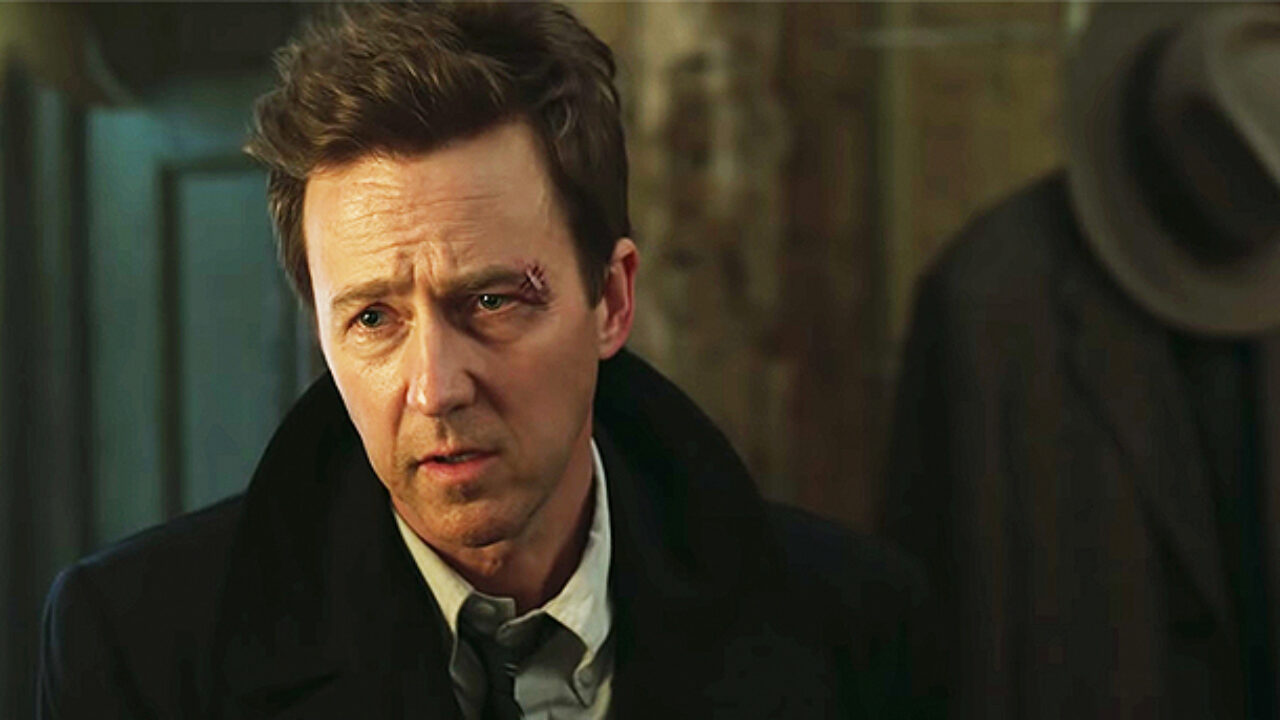Describe the significance of the hat rack in the background. The hat rack in the background, while a seemingly minor detail, serves to ground the scene in a particular setting. It suggests an indoor space, which could be a personal office or a part of a larger household. The presence of the hat indicates a sense of decorum and the importance of appearances, highlighting the formality of the individual’s attire. This small detail adds to the narrative by suggesting he has arrived from or is about to embark on a significant encounter. Can you weave a creative storyline around the scene depicted in the image? Sure! Let's imagine a scenario where this individual is a private detective named Harold, who has a reputation for solving the most convoluted cases. He has just come back to his office after receiving a tip from an anonymous source revealing the whereabouts of a long-missing rare artifact. The tip-off had led him to a dimly lit alleyway where he got into a scuffle, resulting in the disheveled hair and the concern etched on his face. The hat rack in the background holds the hat of his late mentor, a constant reminder of the legacy he strives to uphold. As he stands there, in the dimly lit room, he realizes the gravity of the new clue in his hand – a key to a forgotten crypt under the city's oldest church. The scene captures the moment Harold weighs his next move, teetering on the edge of a breakthrough. What realistic scenario could this image represent? Realistically, this image could represent a moment in an intense business negotiation where the individual has just heard unsettling news about a major deal. The formal suit and tie indicate professionalism, while his concerned and slightly disheveled look suggests the gravity of the situation. Maybe he received a call about a significant stock drop or a breach of contract that puts his company at risk. The dimly lit setting could be his private study or office where he processes critical information. Describe the importance of the individual's disheveled hair in the context of this image. The disheveled hair is a subtle yet telling detail that speaks volumes about the individual's state of mind. Despite his formal attire, the messy hair indicates a break in composure, suggesting he has been under considerable stress or has been through a physically demanding experience. It contrasts with the otherwise neat and formal appearance, highlighting the chaos of the moment or the inner turmoil he is experiencing. This element adds depth to the character and the scene, making the moment captured in the image more compelling and relatable. 